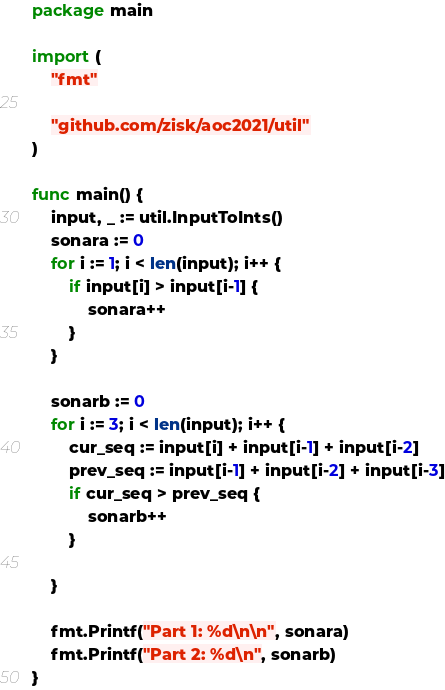Convert code to text. <code><loc_0><loc_0><loc_500><loc_500><_Go_>package main

import (
	"fmt"

	"github.com/zisk/aoc2021/util"
)

func main() {
	input, _ := util.InputToInts()
	sonara := 0
	for i := 1; i < len(input); i++ {
		if input[i] > input[i-1] {
			sonara++
		}
	}

	sonarb := 0
	for i := 3; i < len(input); i++ {
		cur_seq := input[i] + input[i-1] + input[i-2]
		prev_seq := input[i-1] + input[i-2] + input[i-3]
		if cur_seq > prev_seq {
			sonarb++
		}

	}

	fmt.Printf("Part 1: %d\n\n", sonara)
	fmt.Printf("Part 2: %d\n", sonarb)
}
</code> 